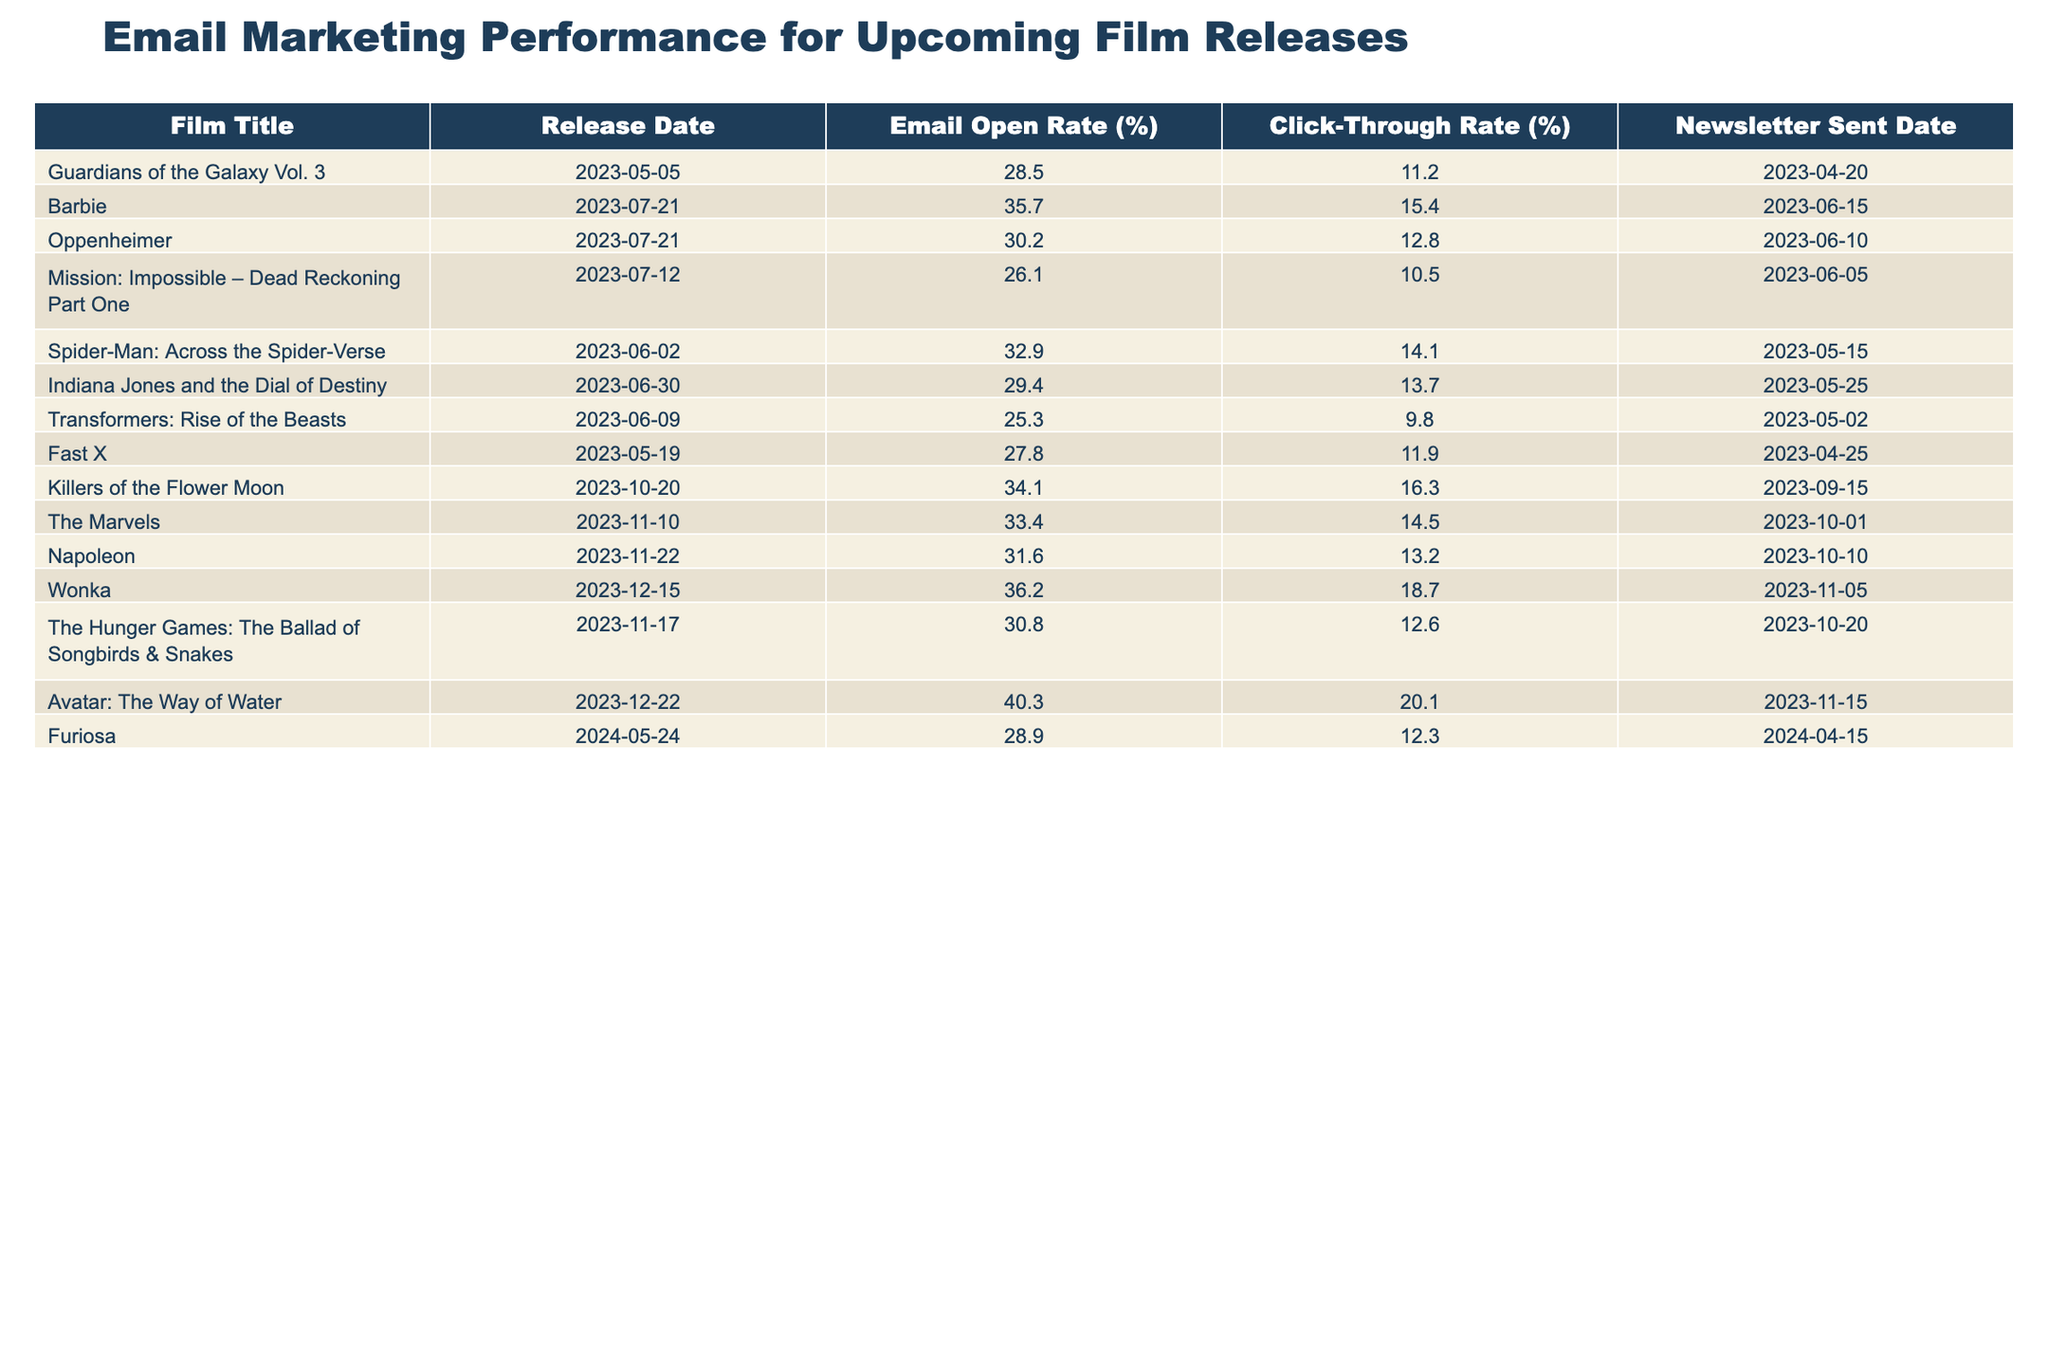What is the highest email open rate among the films listed? The table indicates the email open rates for each film. The highest value is 40.3 for "Avatar: The Way of Water."
Answer: 40.3 Which film had the lowest click-through rate? By examining the click-through rates in the table, "Transformers: Rise of the Beasts" has the lowest rate at 9.8.
Answer: 9.8 What is the email open rate for "Barbie"? Referring to the table, "Barbie" has an email open rate of 35.7%.
Answer: 35.7 Which two films sent newsletters on the same date? Looking at the Newsletter Sent Date, "Oppenheimer" and "Barbie" both have a release date of 2023-07-21, but the newsletters were sent out on different dates: 2023-06-10 for "Oppenheimer" and 2023-06-15 for "Barbie." Therefore, no two films share the exact sent date.
Answer: No What is the average click-through rate for the films released in 2023? To find the average click-through rate, sum the individual rates for the films released in 2023 (11.2 + 15.4 + 12.8 + 10.5 + 14.1 + 13.7 + 9.8 + 11.9 + 16.3 + 14.5 + 13.2 + 18.7 + 12.6 + 20.1) = 16.0, and divide by the number of films (14), resulting in an average of 14.8%.
Answer: 14.8 Is there a film with an email open rate above 35% and a click-through rate above 15%? Checking the table, both "Barbie" (35.7, 15.4) and "Wonka" (36.2, 18.7) meet these criteria.
Answer: Yes Which film had the highest click-through rate and what was that rate? Reviewing the table, "Wonka" has the highest click-through rate at 18.7.
Answer: 18.7 What is the difference between the open rates of "Spider-Man: Across the Spider-Verse" and "Mission: Impossible – Dead Reckoning Part One"? The open rate for "Spider-Man: Across the Spider-Verse" is 32.9 and for "Mission: Impossible – Dead Reckoning Part One" it is 26.1. The difference is 32.9 - 26.1 = 6.8.
Answer: 6.8 Which two films released closest together in terms of their release dates? Comparing all release dates, "Barbie" and "Oppenheimer" both release on the same day, July 21, 2023, being the closest.
Answer: Barbie and Oppenheimer What is the email open rate for films released in December 2023? Only "Avatar: The Way of Water" (40.3) and "Wonka" (36.2) are scheduled for December; thus, the open rates are 40.3 and 36.2.
Answer: 40.3 and 36.2 Do any of the films have a higher click-through rate than their open rate? Checking the click-through rates compared to their corresponding open rates, "Wonka" (36.2, 18.7) shows a higher open rate than click-through. The same goes for all the films reviewed.
Answer: No 